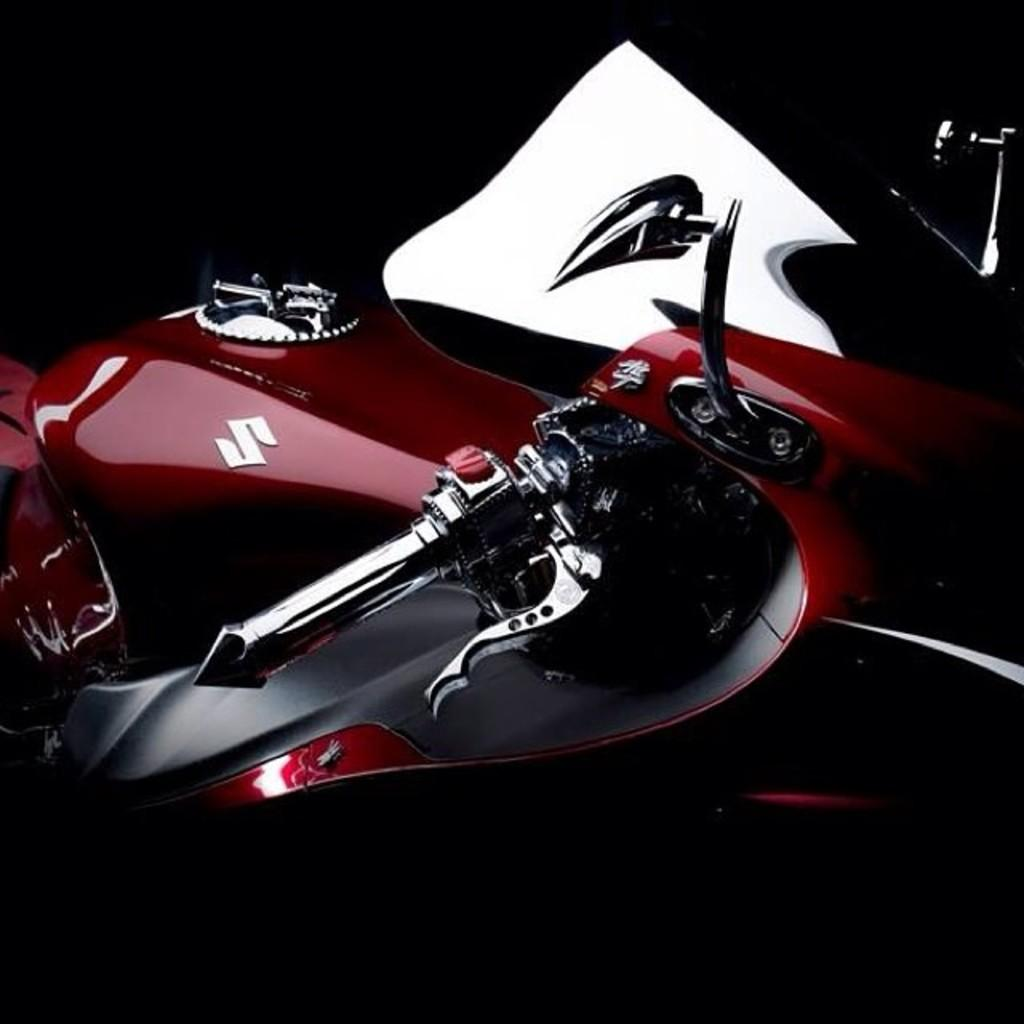What is the main subject of the image? The main subject of the image is a vehicle. Does the vehicle have any distinguishing features? Yes, the vehicle has a logo. What can be observed about the background of the image? The background of the image is dark. What type of channel can be seen running through the image? There is no channel present in the image; it features a vehicle with a logo and a dark background. How many deer are visible in the image? There are no deer present in the image. 